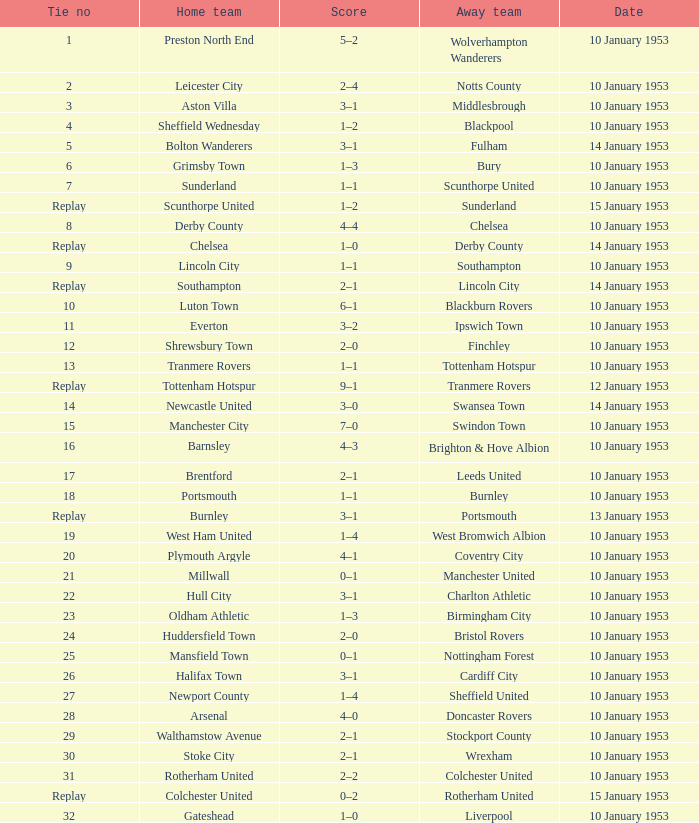What home team has coventry city as the away team? Plymouth Argyle. Can you give me this table as a dict? {'header': ['Tie no', 'Home team', 'Score', 'Away team', 'Date'], 'rows': [['1', 'Preston North End', '5–2', 'Wolverhampton Wanderers', '10 January 1953'], ['2', 'Leicester City', '2–4', 'Notts County', '10 January 1953'], ['3', 'Aston Villa', '3–1', 'Middlesbrough', '10 January 1953'], ['4', 'Sheffield Wednesday', '1–2', 'Blackpool', '10 January 1953'], ['5', 'Bolton Wanderers', '3–1', 'Fulham', '14 January 1953'], ['6', 'Grimsby Town', '1–3', 'Bury', '10 January 1953'], ['7', 'Sunderland', '1–1', 'Scunthorpe United', '10 January 1953'], ['Replay', 'Scunthorpe United', '1–2', 'Sunderland', '15 January 1953'], ['8', 'Derby County', '4–4', 'Chelsea', '10 January 1953'], ['Replay', 'Chelsea', '1–0', 'Derby County', '14 January 1953'], ['9', 'Lincoln City', '1–1', 'Southampton', '10 January 1953'], ['Replay', 'Southampton', '2–1', 'Lincoln City', '14 January 1953'], ['10', 'Luton Town', '6–1', 'Blackburn Rovers', '10 January 1953'], ['11', 'Everton', '3–2', 'Ipswich Town', '10 January 1953'], ['12', 'Shrewsbury Town', '2–0', 'Finchley', '10 January 1953'], ['13', 'Tranmere Rovers', '1–1', 'Tottenham Hotspur', '10 January 1953'], ['Replay', 'Tottenham Hotspur', '9–1', 'Tranmere Rovers', '12 January 1953'], ['14', 'Newcastle United', '3–0', 'Swansea Town', '14 January 1953'], ['15', 'Manchester City', '7–0', 'Swindon Town', '10 January 1953'], ['16', 'Barnsley', '4–3', 'Brighton & Hove Albion', '10 January 1953'], ['17', 'Brentford', '2–1', 'Leeds United', '10 January 1953'], ['18', 'Portsmouth', '1–1', 'Burnley', '10 January 1953'], ['Replay', 'Burnley', '3–1', 'Portsmouth', '13 January 1953'], ['19', 'West Ham United', '1–4', 'West Bromwich Albion', '10 January 1953'], ['20', 'Plymouth Argyle', '4–1', 'Coventry City', '10 January 1953'], ['21', 'Millwall', '0–1', 'Manchester United', '10 January 1953'], ['22', 'Hull City', '3–1', 'Charlton Athletic', '10 January 1953'], ['23', 'Oldham Athletic', '1–3', 'Birmingham City', '10 January 1953'], ['24', 'Huddersfield Town', '2–0', 'Bristol Rovers', '10 January 1953'], ['25', 'Mansfield Town', '0–1', 'Nottingham Forest', '10 January 1953'], ['26', 'Halifax Town', '3–1', 'Cardiff City', '10 January 1953'], ['27', 'Newport County', '1–4', 'Sheffield United', '10 January 1953'], ['28', 'Arsenal', '4–0', 'Doncaster Rovers', '10 January 1953'], ['29', 'Walthamstow Avenue', '2–1', 'Stockport County', '10 January 1953'], ['30', 'Stoke City', '2–1', 'Wrexham', '10 January 1953'], ['31', 'Rotherham United', '2–2', 'Colchester United', '10 January 1953'], ['Replay', 'Colchester United', '0–2', 'Rotherham United', '15 January 1953'], ['32', 'Gateshead', '1–0', 'Liverpool', '10 January 1953']]} 